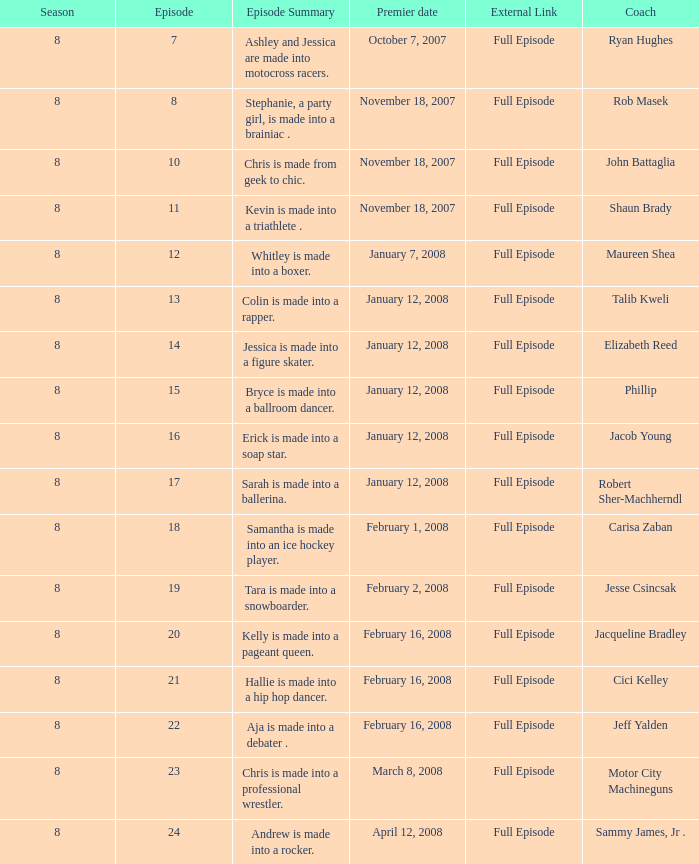Who was the instructor for episode 15? Phillip. 